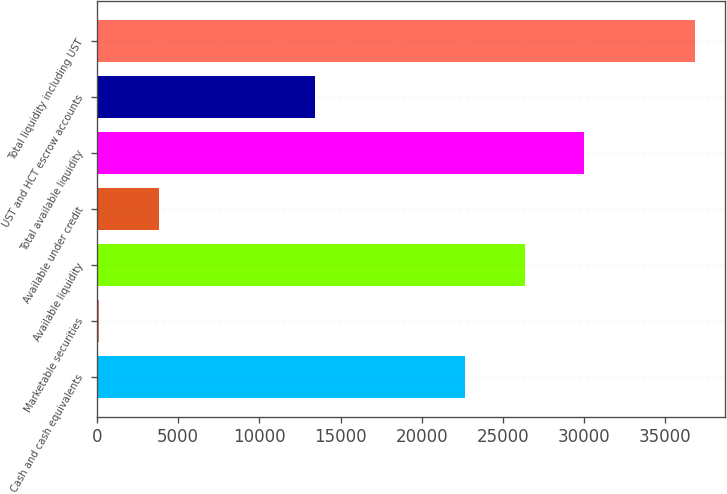Convert chart to OTSL. <chart><loc_0><loc_0><loc_500><loc_500><bar_chart><fcel>Cash and cash equivalents<fcel>Marketable securities<fcel>Available liquidity<fcel>Available under credit<fcel>Total available liquidity<fcel>UST and HCT escrow accounts<fcel>Total liquidity including UST<nl><fcel>22679<fcel>134<fcel>26351.7<fcel>3806.7<fcel>30024.4<fcel>13430<fcel>36861<nl></chart> 